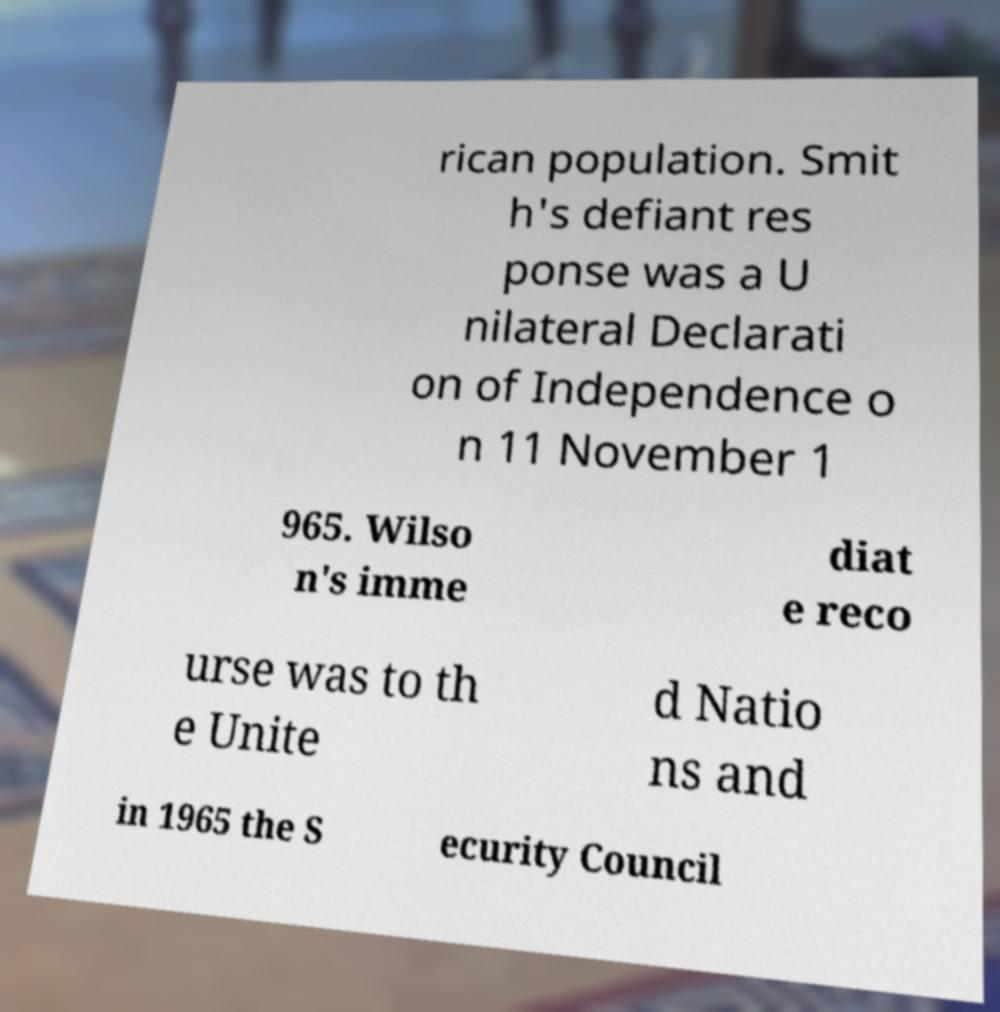Can you read and provide the text displayed in the image?This photo seems to have some interesting text. Can you extract and type it out for me? rican population. Smit h's defiant res ponse was a U nilateral Declarati on of Independence o n 11 November 1 965. Wilso n's imme diat e reco urse was to th e Unite d Natio ns and in 1965 the S ecurity Council 